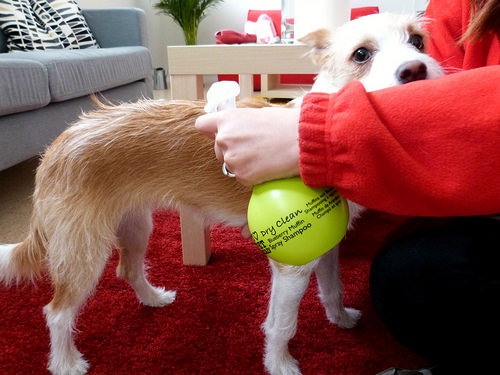<image>
Is the dog in front of the spray bottle? No. The dog is not in front of the spray bottle. The spatial positioning shows a different relationship between these objects. 